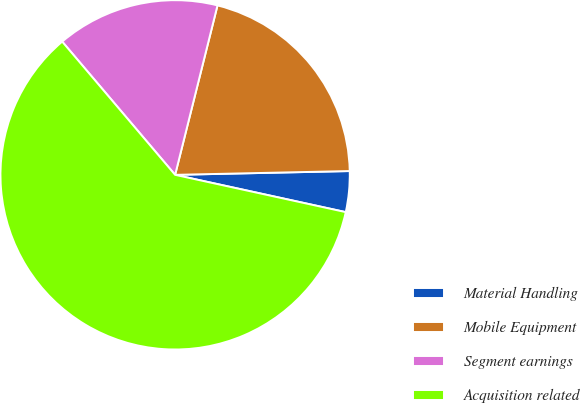Convert chart. <chart><loc_0><loc_0><loc_500><loc_500><pie_chart><fcel>Material Handling<fcel>Mobile Equipment<fcel>Segment earnings<fcel>Acquisition related<nl><fcel>3.77%<fcel>20.75%<fcel>15.09%<fcel>60.38%<nl></chart> 